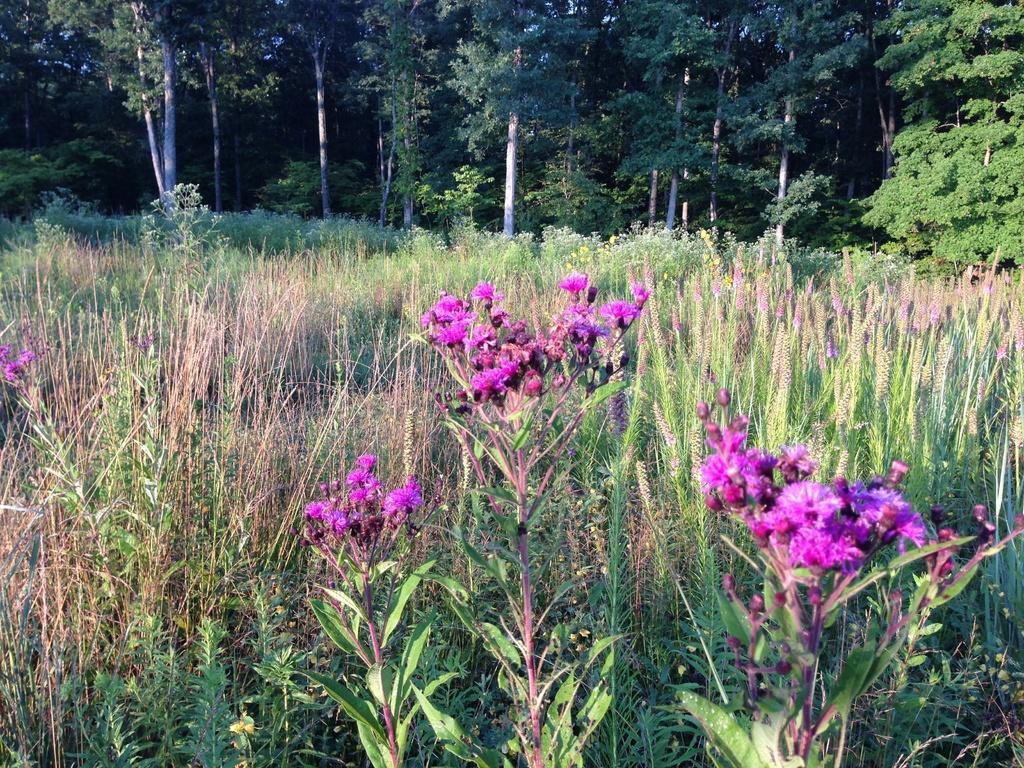Could you give a brief overview of what you see in this image? In this picture we can see flowers, plants and in the background we can see trees. 